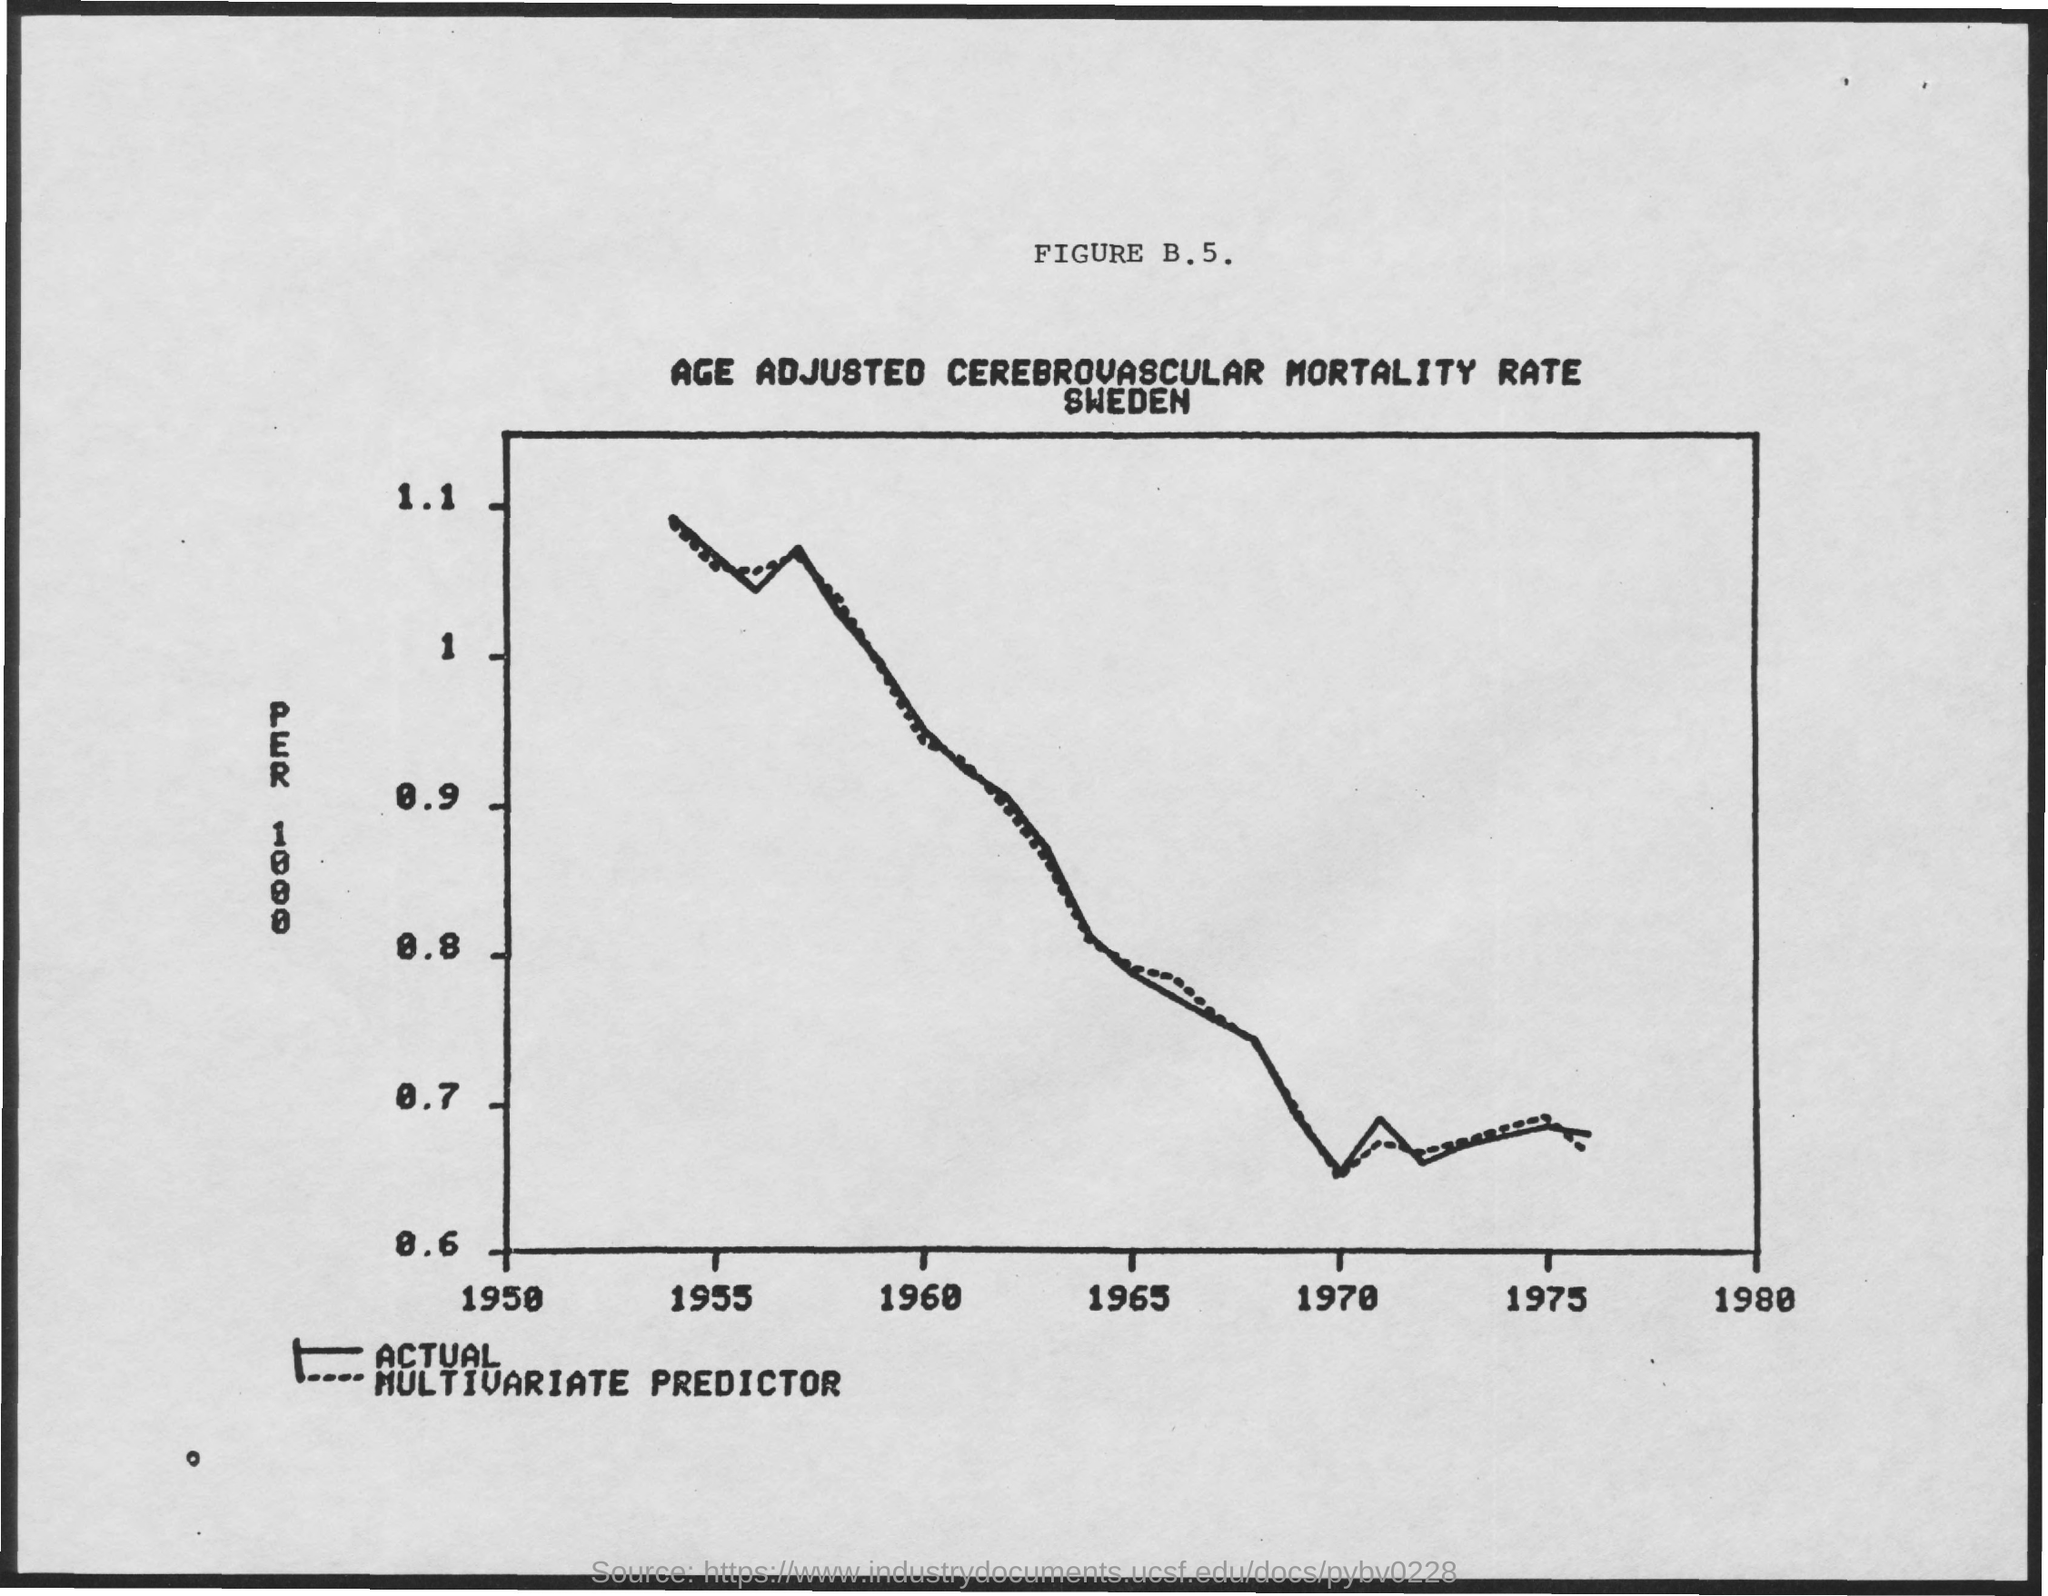What is the title of the graph?
Ensure brevity in your answer.  Age adjusted cerebrovascular mortality rate sweden. 